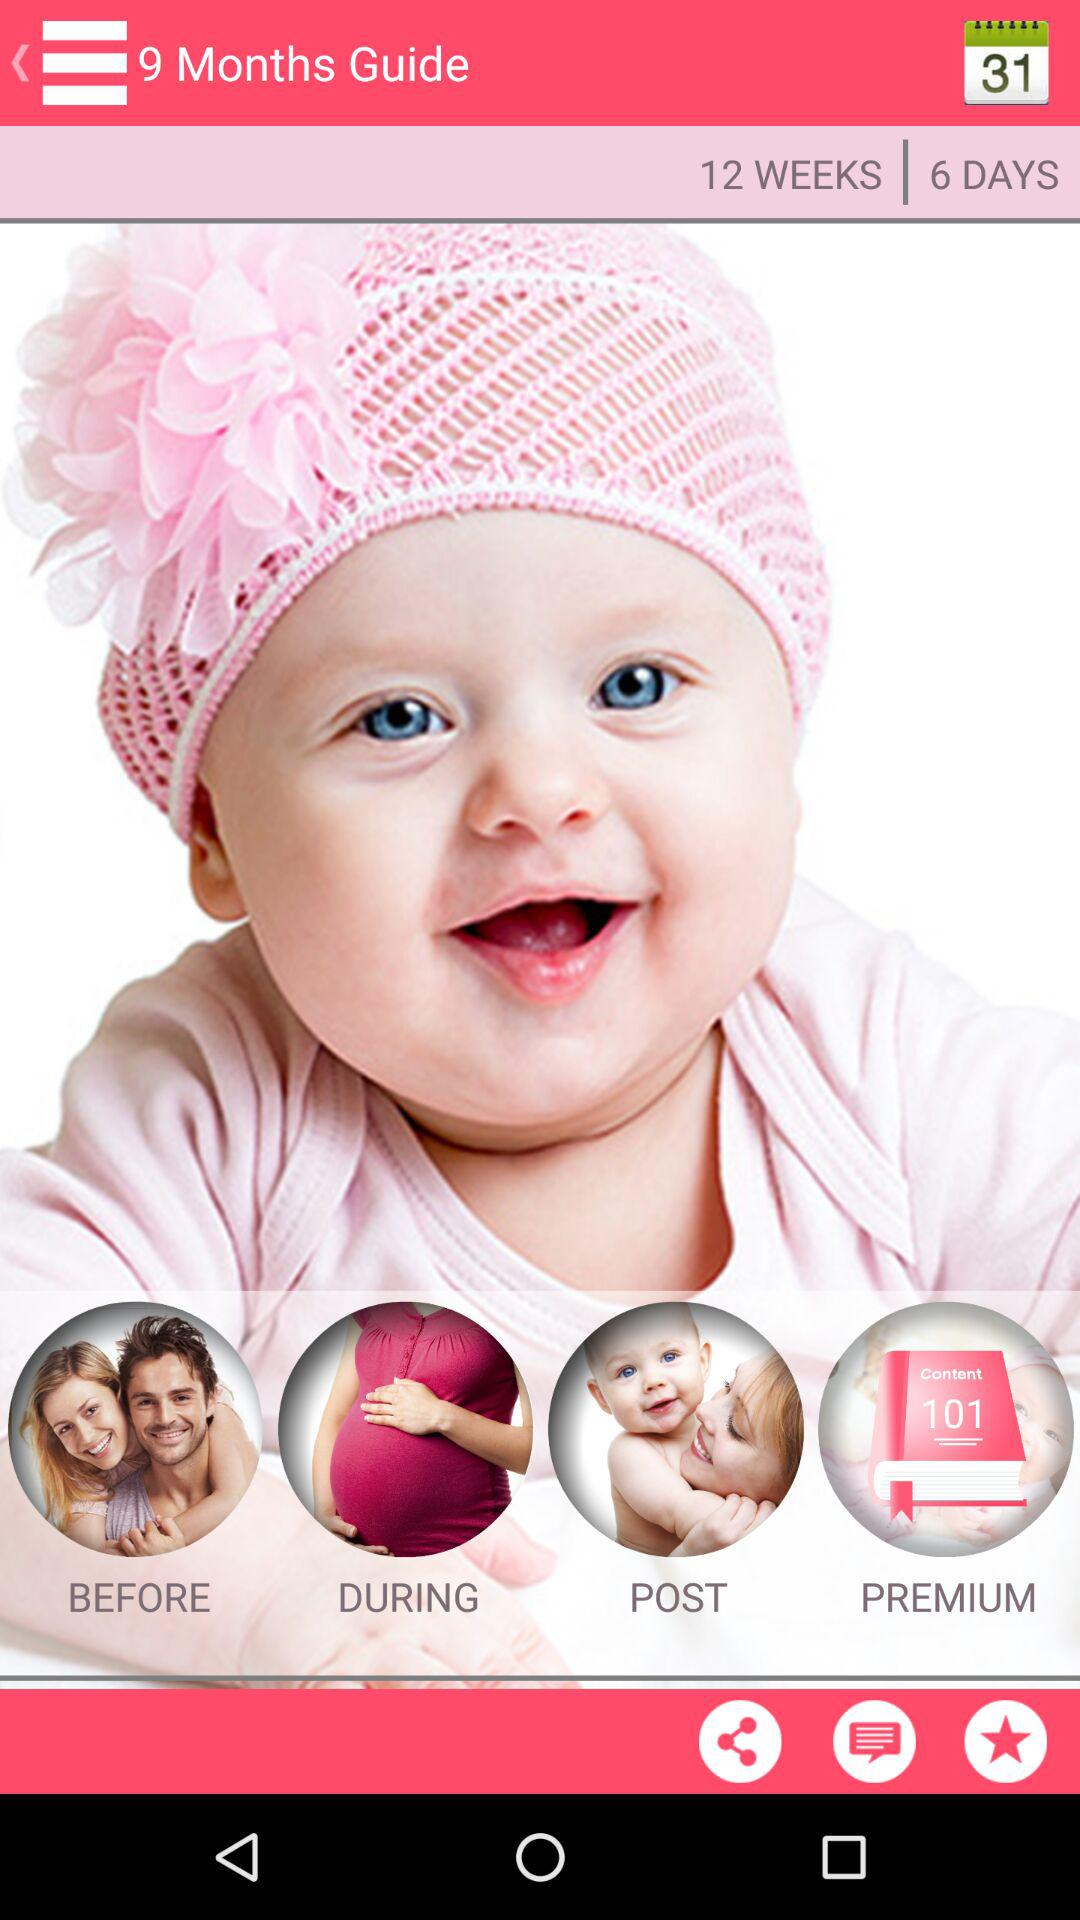What is the application name? The application name is "9 Months Guide". 